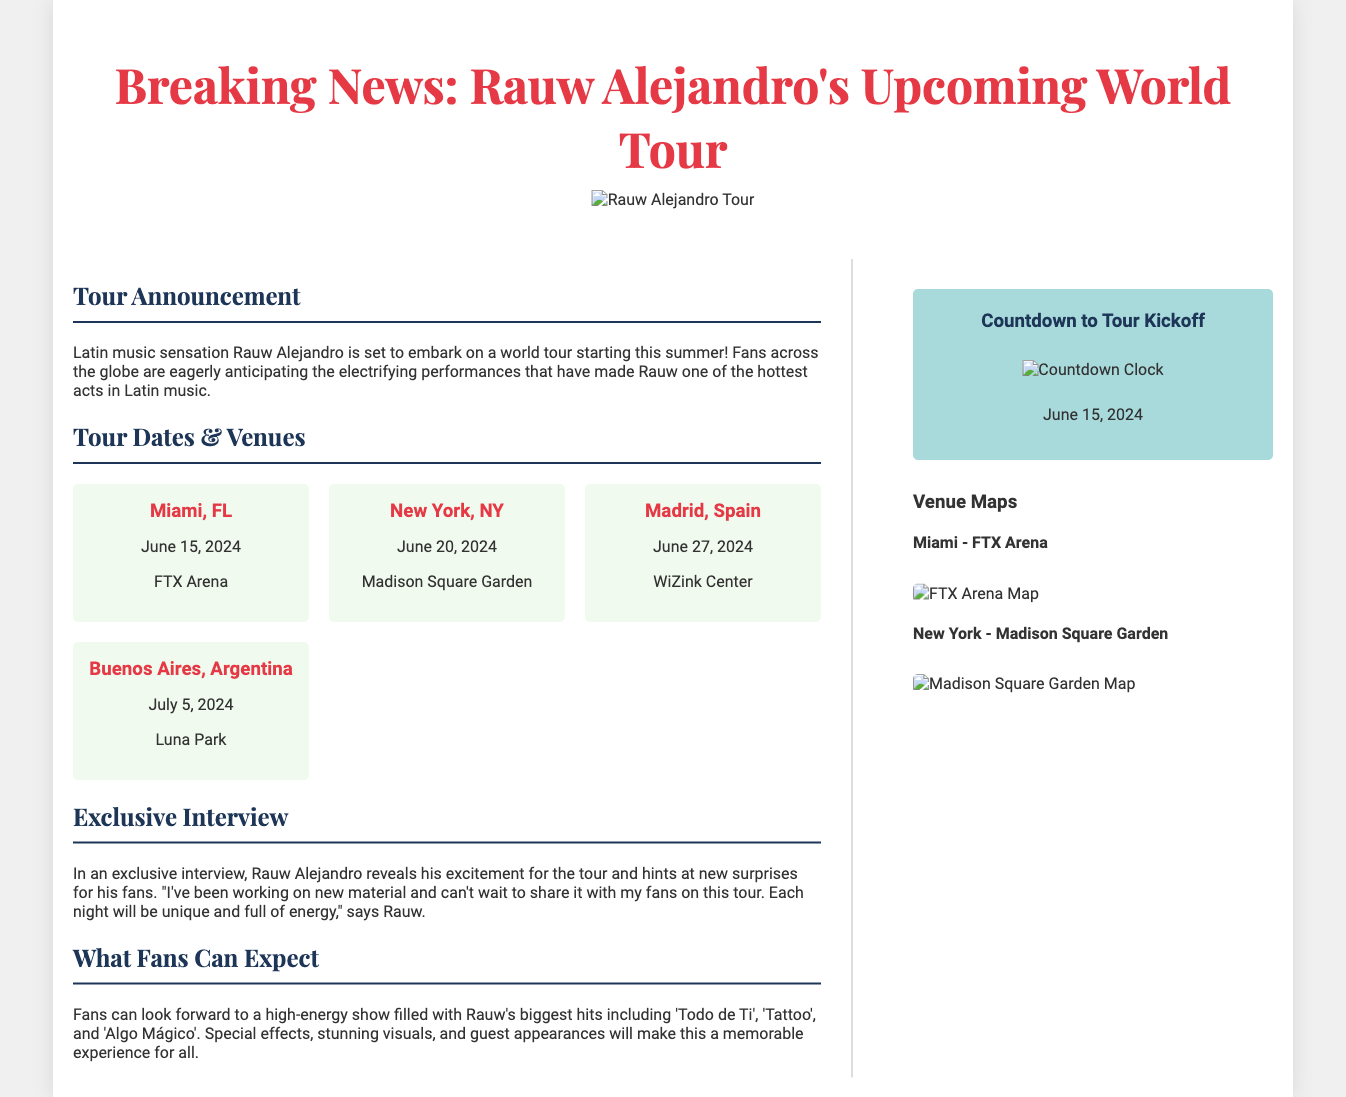What is the title of the article? The title of the article prominently displayed at the top of the document is "Breaking News: Rauw Alejandro's Upcoming World Tour".
Answer: Breaking News: Rauw Alejandro's Upcoming World Tour When does the tour start? The document states that Rauw Alejandro's world tour is set to start on June 15, 2024.
Answer: June 15, 2024 What venue will Rauw Alejandro perform at in New York? The venue in New York listed in the document is Madison Square Garden.
Answer: Madison Square Garden What is highlighted in the exclusive interview with Rauw Alejandro? The interview reveals Rauw's excitement for the tour and mentions he has been working on new material.
Answer: New material How many tour dates are listed in the document? The document lists four specific tour dates, one for each city mentioned.
Answer: Four What special feature will enhance the concert experience for fans? The document mentions that special effects and stunning visuals will enhance the concert experience.
Answer: Special effects and stunning visuals What image accompanies the countdown section? In the countdown section, an image of a countdown clock is included.
Answer: Countdown clock Which city has the earliest concert date? The city with the earliest concert date, according to the tour dates section, is Miami.
Answer: Miami 